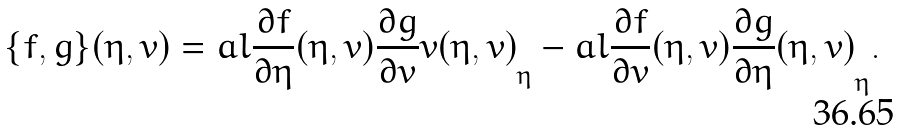Convert formula to latex. <formula><loc_0><loc_0><loc_500><loc_500>\{ f , g \} ( \eta , v ) = a l { \frac { \partial f } { \partial \eta } ( \eta , v ) } { \frac { \partial g } { \partial v } { v } ( \eta , v ) } _ { \eta } - a l { \frac { \partial f } { \partial v } ( \eta , v ) } { \frac { \partial g } { \partial \eta } ( \eta , v ) } _ { \eta } .</formula> 